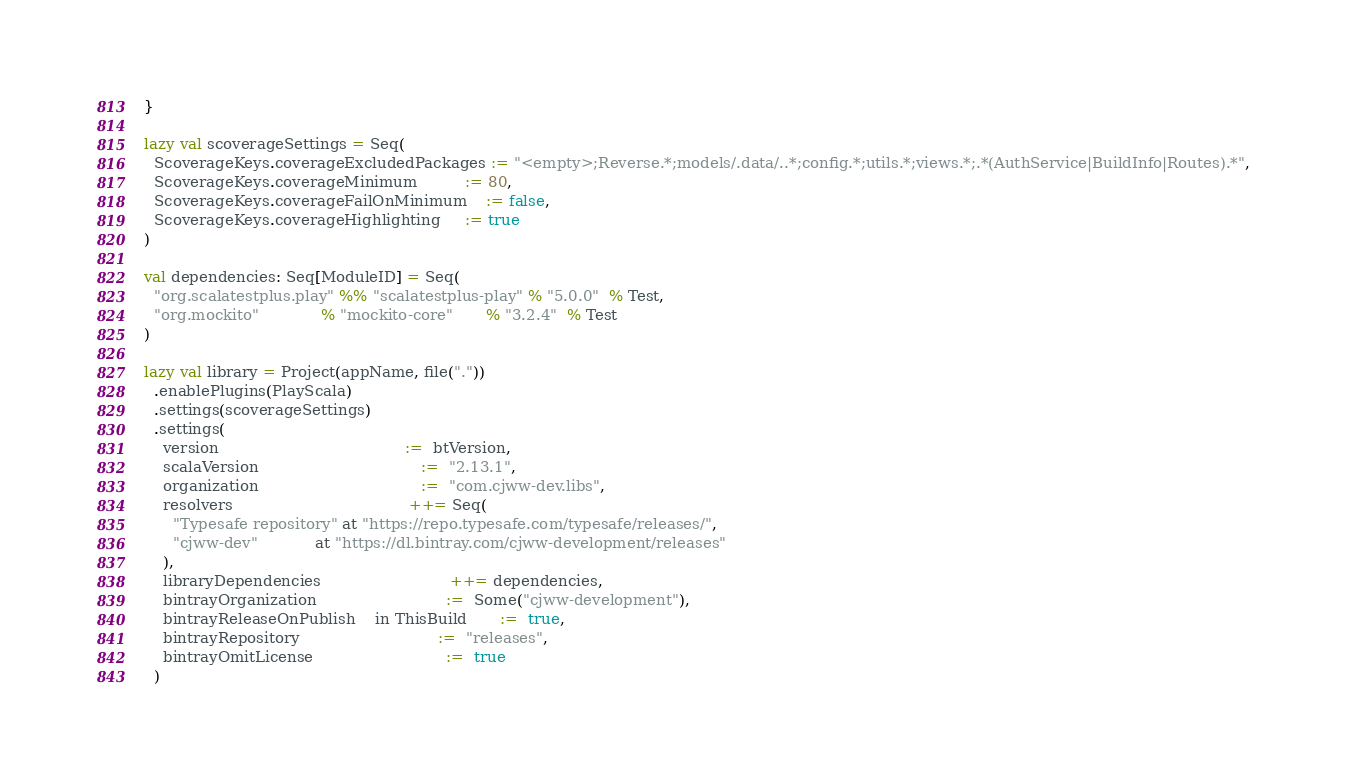<code> <loc_0><loc_0><loc_500><loc_500><_Scala_>}

lazy val scoverageSettings = Seq(
  ScoverageKeys.coverageExcludedPackages := "<empty>;Reverse.*;models/.data/..*;config.*;utils.*;views.*;.*(AuthService|BuildInfo|Routes).*",
  ScoverageKeys.coverageMinimum          := 80,
  ScoverageKeys.coverageFailOnMinimum    := false,
  ScoverageKeys.coverageHighlighting     := true
)

val dependencies: Seq[ModuleID] = Seq(
  "org.scalatestplus.play" %% "scalatestplus-play" % "5.0.0"  % Test,
  "org.mockito"             % "mockito-core"       % "3.2.4"  % Test
)

lazy val library = Project(appName, file("."))
  .enablePlugins(PlayScala)
  .settings(scoverageSettings)
  .settings(
    version                                       :=  btVersion,
    scalaVersion                                  :=  "2.13.1",
    organization                                  :=  "com.cjww-dev.libs",
    resolvers                                     ++= Seq(
      "Typesafe repository" at "https://repo.typesafe.com/typesafe/releases/",
      "cjww-dev"            at "https://dl.bintray.com/cjww-development/releases"
    ),
    libraryDependencies                           ++= dependencies,
    bintrayOrganization                           :=  Some("cjww-development"),
    bintrayReleaseOnPublish    in ThisBuild       :=  true,
    bintrayRepository                             :=  "releases",
    bintrayOmitLicense                            :=  true
  )
</code> 